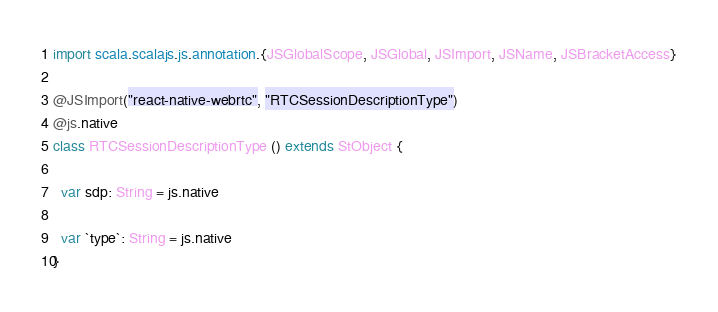Convert code to text. <code><loc_0><loc_0><loc_500><loc_500><_Scala_>import scala.scalajs.js.annotation.{JSGlobalScope, JSGlobal, JSImport, JSName, JSBracketAccess}

@JSImport("react-native-webrtc", "RTCSessionDescriptionType")
@js.native
class RTCSessionDescriptionType () extends StObject {
  
  var sdp: String = js.native
  
  var `type`: String = js.native
}
</code> 